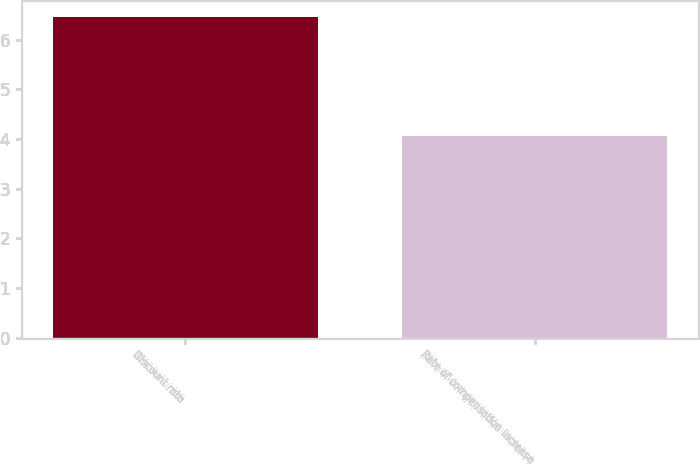<chart> <loc_0><loc_0><loc_500><loc_500><bar_chart><fcel>Discount rate<fcel>Rate of compensation increase<nl><fcel>6.45<fcel>4.06<nl></chart> 